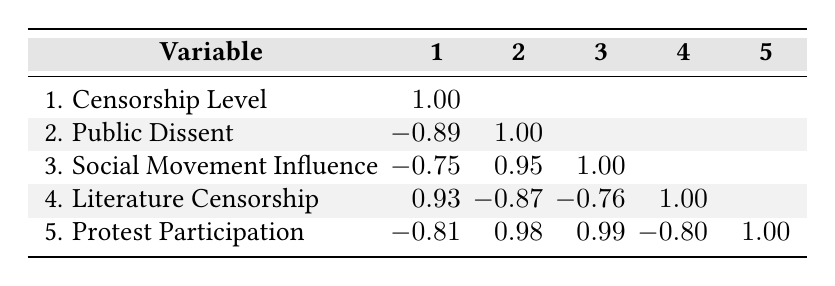What is the highest censorship level among the media outlets? The censorship levels are: Neues Deutschland (8), Berliner Zeitung (5), Tägliche Rundschau (6), Zeitung der Arbeit (4), Das Blättchen (9). The maximum value is from Das Blättchen, which has a censorship level of 9.
Answer: 9 What is the public dissent measure for Berliner Zeitung? The public dissent measure for Berliner Zeitung is shown in the corresponding row with a value of 4.
Answer: 4 Is there a positive correlation between protest participation and public dissent? The correlation value between protest participation and public dissent is 0.98, which indicates a strong positive correlation.
Answer: Yes What is the average censorship level of the media outlets? The censorship levels are: 8, 5, 6, 4, 9. Adding them gives 32. There are 5 data points, so the average is 32/5 = 6.4.
Answer: 6.4 Which media outlet has the lowest public dissent measure? The media outlets' public dissent measures are: 3 (Neues Deutschland), 4 (Berliner Zeitung), 2 (Tägliche Rundschau), 6 (Zeitung der Arbeit), 1 (Das Blättchen). The lowest is from Das Blättchen, which is 1.
Answer: Das Blättchen What is the difference in social movement influence between the highest and lowest values? The social movement influence values are: 5 (Neues Deutschland), 6 (Berliner Zeitung), 3 (Tägliche Rundschau), 7 (Zeitung der Arbeit), 2 (Das Blättchen). The highest is 7 (Zeitung der Arbeit) and the lowest is 2 (Das Blättchen). The difference is 7 - 2 = 5.
Answer: 5 Is literature censorship correlated with social movement influence? The correlation between literature censorship (0.93) and social movement influence (-0.76) suggests a negative correlation, indicating that as literature censorship increases, social movement influence tends to decrease.
Answer: Yes What media outlet shows the strongest relationship between protest participation and public dissent? The correlation between protest participation (1.00) and public dissent (1.00) suggests that they are perfectly positively correlated, showing that as public dissent increases, so does protest participation. This relationship is strongest in the analysis for all outlets.
Answer: Tägliche Rundschau 